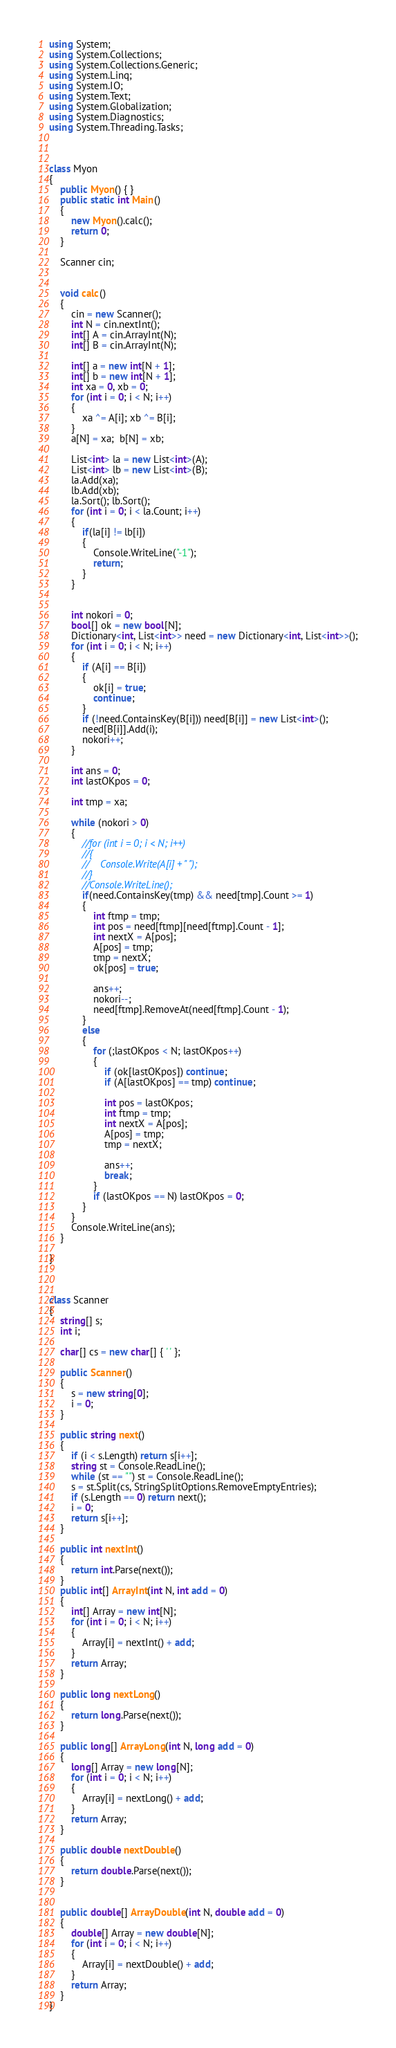<code> <loc_0><loc_0><loc_500><loc_500><_C#_>using System;
using System.Collections;
using System.Collections.Generic;
using System.Linq;
using System.IO;
using System.Text;
using System.Globalization;
using System.Diagnostics;
using System.Threading.Tasks;



class Myon
{
    public Myon() { }
    public static int Main()
    {
        new Myon().calc();
        return 0;
    }

    Scanner cin;


    void calc()
    {
        cin = new Scanner();
        int N = cin.nextInt();
        int[] A = cin.ArrayInt(N);
        int[] B = cin.ArrayInt(N);

        int[] a = new int[N + 1];
        int[] b = new int[N + 1];
        int xa = 0, xb = 0;
        for (int i = 0; i < N; i++)
        {
            xa ^= A[i]; xb ^= B[i];
        }
        a[N] = xa;  b[N] = xb;

        List<int> la = new List<int>(A);
        List<int> lb = new List<int>(B);
        la.Add(xa);
        lb.Add(xb);
        la.Sort(); lb.Sort();
        for (int i = 0; i < la.Count; i++)
        {
            if(la[i] != lb[i])
            {
                Console.WriteLine("-1");
                return;
            }
        }


        int nokori = 0;
        bool[] ok = new bool[N];
        Dictionary<int, List<int>> need = new Dictionary<int, List<int>>();
        for (int i = 0; i < N; i++)
        {
            if (A[i] == B[i])
            {
                ok[i] = true;
                continue;
            }
            if (!need.ContainsKey(B[i])) need[B[i]] = new List<int>();
            need[B[i]].Add(i);
            nokori++;
        }

        int ans = 0;
        int lastOKpos = 0;

        int tmp = xa;

        while (nokori > 0)
        {
            //for (int i = 0; i < N; i++)
            //{
            //    Console.Write(A[i] + " ");
            //}
            //Console.WriteLine();
            if(need.ContainsKey(tmp) && need[tmp].Count >= 1)
            {
                int ftmp = tmp;
                int pos = need[ftmp][need[ftmp].Count - 1];
                int nextX = A[pos];
                A[pos] = tmp;
                tmp = nextX;
                ok[pos] = true;

                ans++;
                nokori--;
                need[ftmp].RemoveAt(need[ftmp].Count - 1);
            }
            else
            {
                for (;lastOKpos < N; lastOKpos++)
                {
                    if (ok[lastOKpos]) continue;
                    if (A[lastOKpos] == tmp) continue;

                    int pos = lastOKpos;
                    int ftmp = tmp;
                    int nextX = A[pos];
                    A[pos] = tmp;
                    tmp = nextX;

                    ans++;
                    break;
                }
                if (lastOKpos == N) lastOKpos = 0;
            }
        }
        Console.WriteLine(ans);
    }

}



class Scanner
{
    string[] s;
    int i;

    char[] cs = new char[] { ' ' };

    public Scanner()
    {
        s = new string[0];
        i = 0;
    }

    public string next()
    {
        if (i < s.Length) return s[i++];
        string st = Console.ReadLine();
        while (st == "") st = Console.ReadLine();
        s = st.Split(cs, StringSplitOptions.RemoveEmptyEntries);
        if (s.Length == 0) return next();
        i = 0;
        return s[i++];
    }

    public int nextInt()
    {
        return int.Parse(next());
    }
    public int[] ArrayInt(int N, int add = 0)
    {
        int[] Array = new int[N];
        for (int i = 0; i < N; i++)
        {
            Array[i] = nextInt() + add;
        }
        return Array;
    }

    public long nextLong()
    {
        return long.Parse(next());
    }

    public long[] ArrayLong(int N, long add = 0)
    {
        long[] Array = new long[N];
        for (int i = 0; i < N; i++)
        {
            Array[i] = nextLong() + add;
        }
        return Array;
    }

    public double nextDouble()
    {
        return double.Parse(next());
    }


    public double[] ArrayDouble(int N, double add = 0)
    {
        double[] Array = new double[N];
        for (int i = 0; i < N; i++)
        {
            Array[i] = nextDouble() + add;
        }
        return Array;
    }
}

</code> 